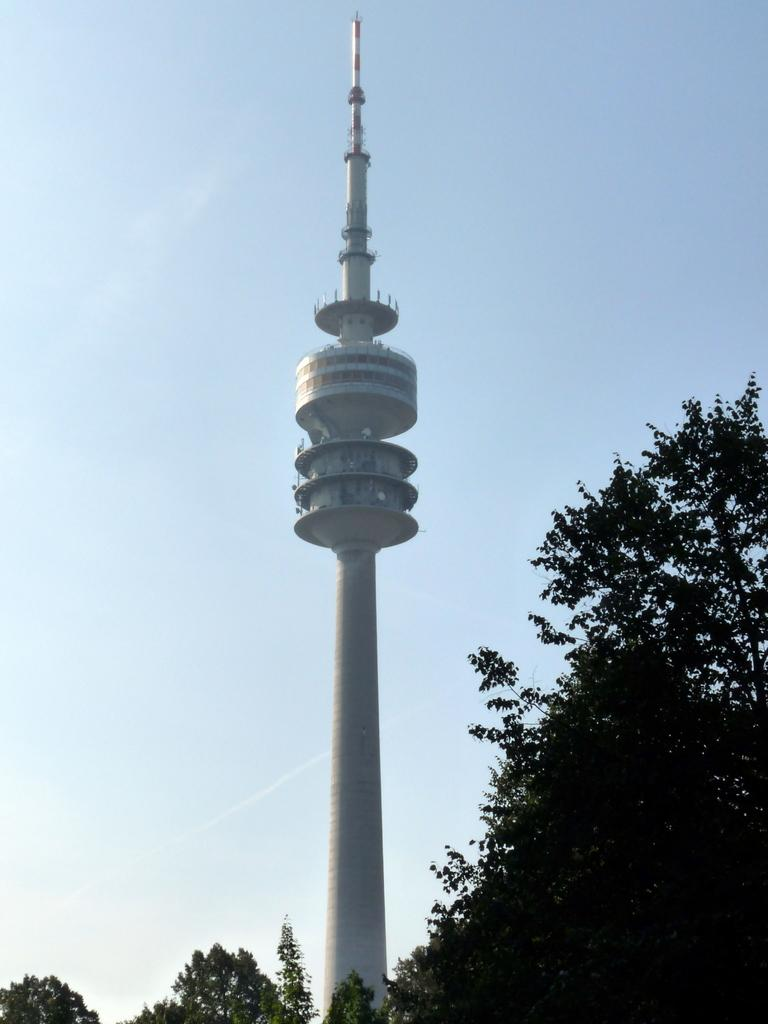What type of vegetation is visible in the front of the image? There are trees in the front of the image. What structure is located in the center of the image? There is a tower in the center of the image. Can you tell me who won the argument between the judge and the trees in the image? There is no argument or judge present in the image; it features trees and a tower. What color are the eyes of the trees in the image? Trees do not have eyes, so this question cannot be answered. 